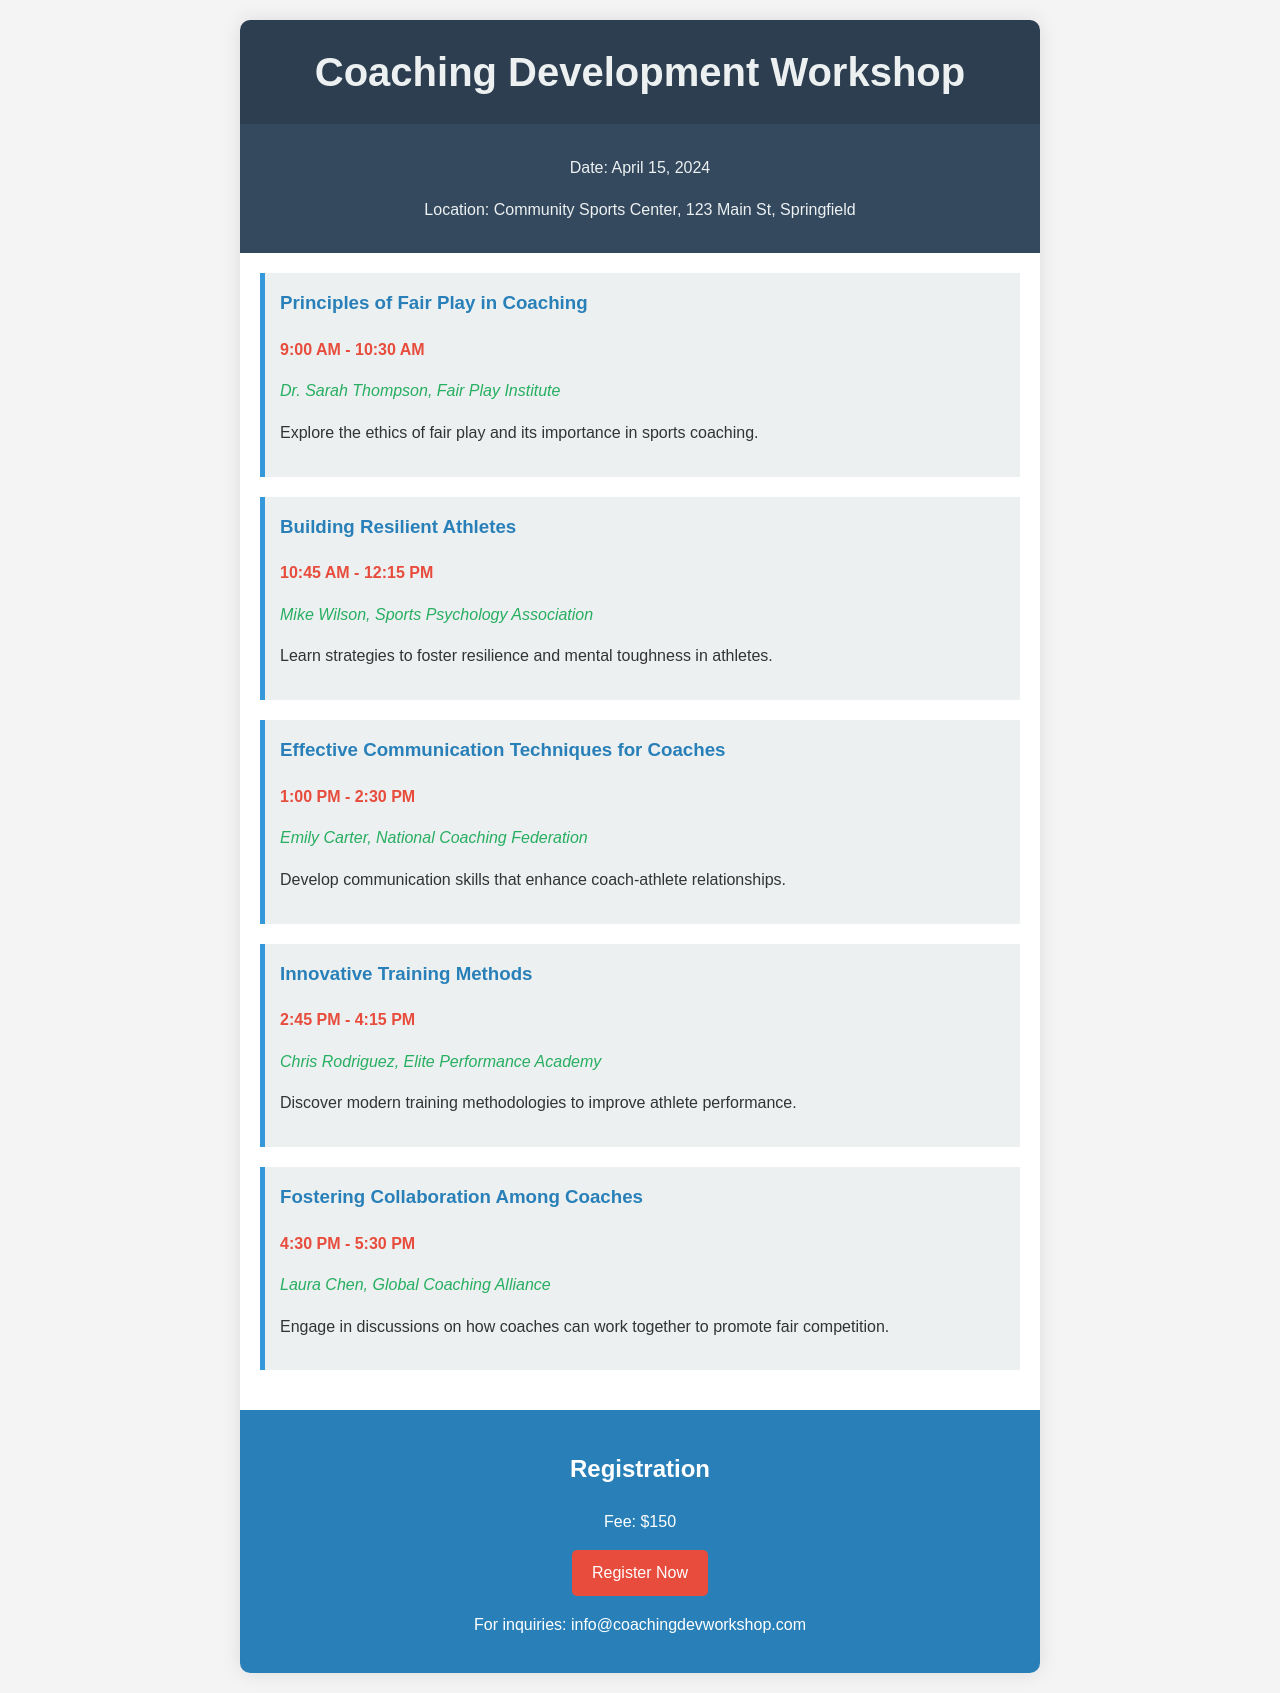What is the date of the workshop? The date of the workshop is explicitly stated in the document, which is April 15, 2024.
Answer: April 15, 2024 Where is the workshop taking place? The location of the workshop is provided in the document as the Community Sports Center, 123 Main St, Springfield.
Answer: Community Sports Center, 123 Main St, Springfield What is the registration fee for the workshop? The fee for registration is mentioned clearly in the document as $150.
Answer: $150 Who is the speaker for the session on Effective Communication Techniques for Coaches? The document lists Emily Carter as the speaker for the session on Effective Communication Techniques for Coaches.
Answer: Emily Carter What topic is discussed in the session that starts at 1:00 PM? The document specifies that the session starting at 1:00 PM focuses on Effective Communication Techniques for Coaches.
Answer: Effective Communication Techniques for Coaches How many sessions are scheduled before lunch? The document states that there are three sessions before lunch, which are Principles of Fair Play in Coaching, Building Resilient Athletes, and Effective Communication Techniques for Coaches.
Answer: Three Which organization is Dr. Sarah Thompson associated with? The document indicates that Dr. Sarah Thompson is from the Fair Play Institute.
Answer: Fair Play Institute What is the purpose of the last session in the schedule? The last session, titled Fostering Collaboration Among Coaches, aims to discuss how coaches can work together to promote fair competition.
Answer: Promote fair competition What color is used for the registration section? The document describes the registration section as having a background color of blue, specifically #2980b9.
Answer: Blue 